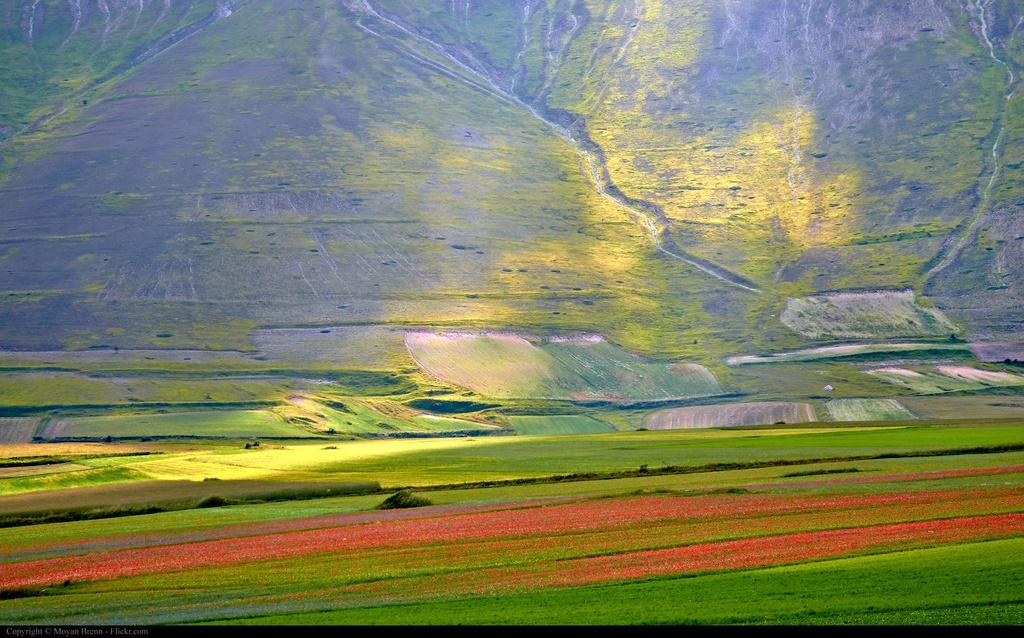What type of natural landscape is depicted in the image? The image features mountains. What other type of land can be seen in the image? There is agricultural land visible in the image. How are the agricultural lands represented in terms of color? The agricultural land is in green and red colors. Are there any visible paths or routes in the image? Yes, there are routes visible in the image. Can you see a pet playing in the grass in the image? There is no pet or grass present in the image. 